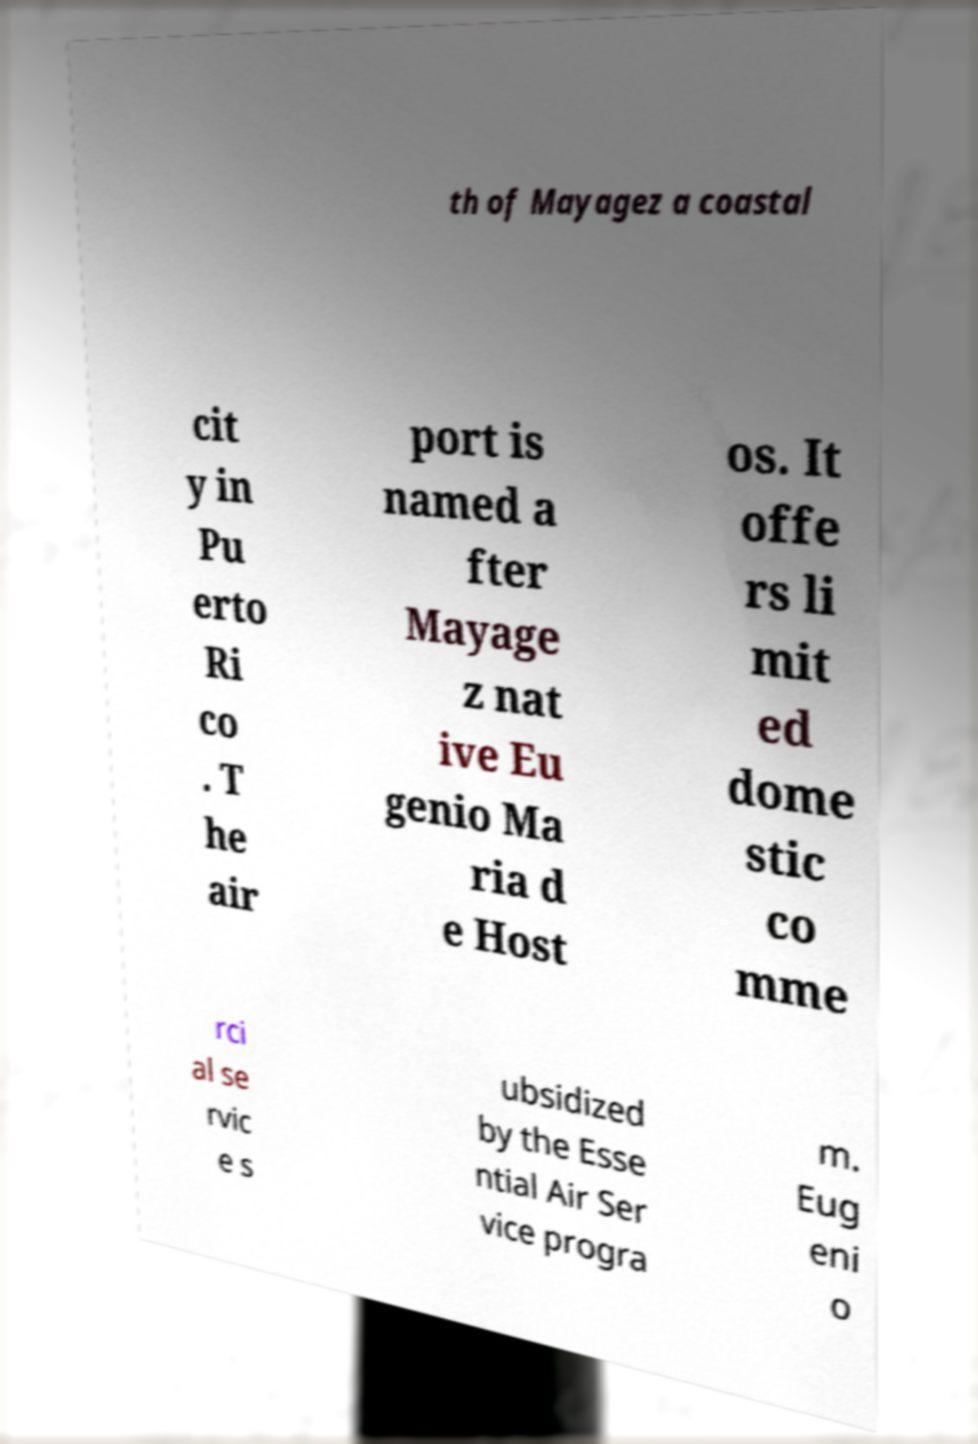For documentation purposes, I need the text within this image transcribed. Could you provide that? th of Mayagez a coastal cit y in Pu erto Ri co . T he air port is named a fter Mayage z nat ive Eu genio Ma ria d e Host os. It offe rs li mit ed dome stic co mme rci al se rvic e s ubsidized by the Esse ntial Air Ser vice progra m. Eug eni o 